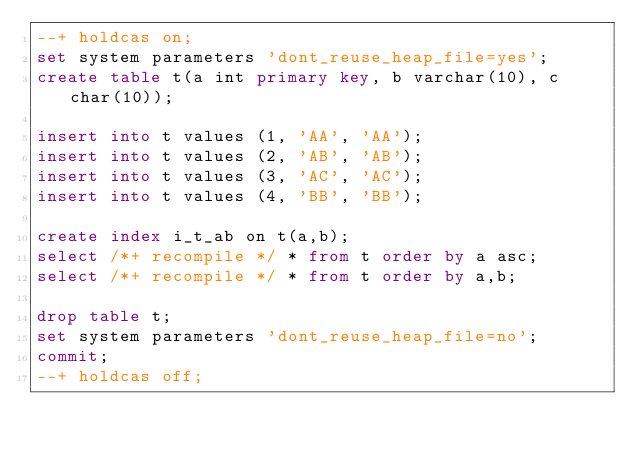<code> <loc_0><loc_0><loc_500><loc_500><_SQL_>--+ holdcas on;
set system parameters 'dont_reuse_heap_file=yes';
create table t(a int primary key, b varchar(10), c char(10));

insert into t values (1, 'AA', 'AA');
insert into t values (2, 'AB', 'AB');
insert into t values (3, 'AC', 'AC');
insert into t values (4, 'BB', 'BB');

create index i_t_ab on t(a,b);
select /*+ recompile */ * from t order by a asc;
select /*+ recompile */ * from t order by a,b;

drop table t;
set system parameters 'dont_reuse_heap_file=no';
commit;
--+ holdcas off;
</code> 